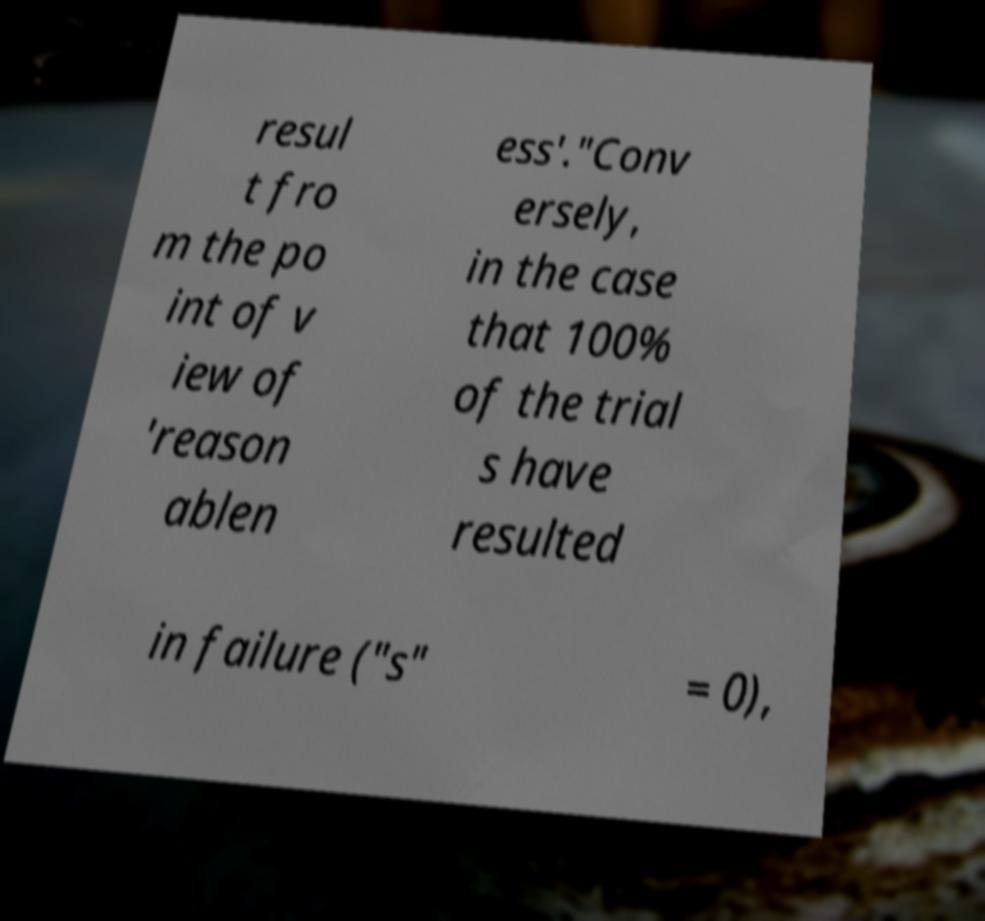Please read and relay the text visible in this image. What does it say? resul t fro m the po int of v iew of 'reason ablen ess'."Conv ersely, in the case that 100% of the trial s have resulted in failure ("s" = 0), 